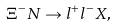Convert formula to latex. <formula><loc_0><loc_0><loc_500><loc_500>\Xi ^ { - } N \to l ^ { + } l ^ { - } X ,</formula> 